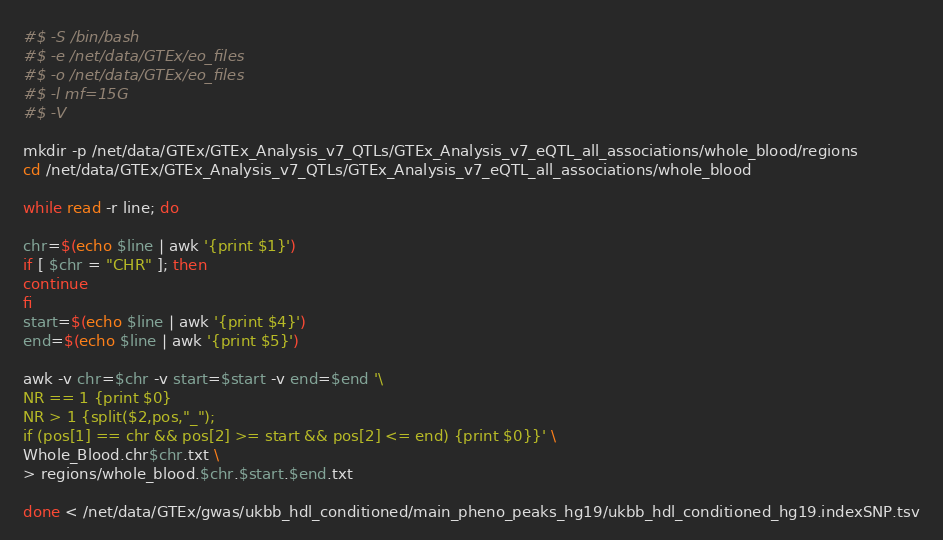<code> <loc_0><loc_0><loc_500><loc_500><_Bash_>#$ -S /bin/bash
#$ -e /net/data/GTEx/eo_files
#$ -o /net/data/GTEx/eo_files
#$ -l mf=15G
#$ -V

mkdir -p /net/data/GTEx/GTEx_Analysis_v7_QTLs/GTEx_Analysis_v7_eQTL_all_associations/whole_blood/regions
cd /net/data/GTEx/GTEx_Analysis_v7_QTLs/GTEx_Analysis_v7_eQTL_all_associations/whole_blood

while read -r line; do

chr=$(echo $line | awk '{print $1}')
if [ $chr = "CHR" ]; then
continue
fi
start=$(echo $line | awk '{print $4}')
end=$(echo $line | awk '{print $5}')

awk -v chr=$chr -v start=$start -v end=$end '\
NR == 1 {print $0}
NR > 1 {split($2,pos,"_");
if (pos[1] == chr && pos[2] >= start && pos[2] <= end) {print $0}}' \
Whole_Blood.chr$chr.txt \
> regions/whole_blood.$chr.$start.$end.txt

done < /net/data/GTEx/gwas/ukbb_hdl_conditioned/main_pheno_peaks_hg19/ukbb_hdl_conditioned_hg19.indexSNP.tsv
</code> 